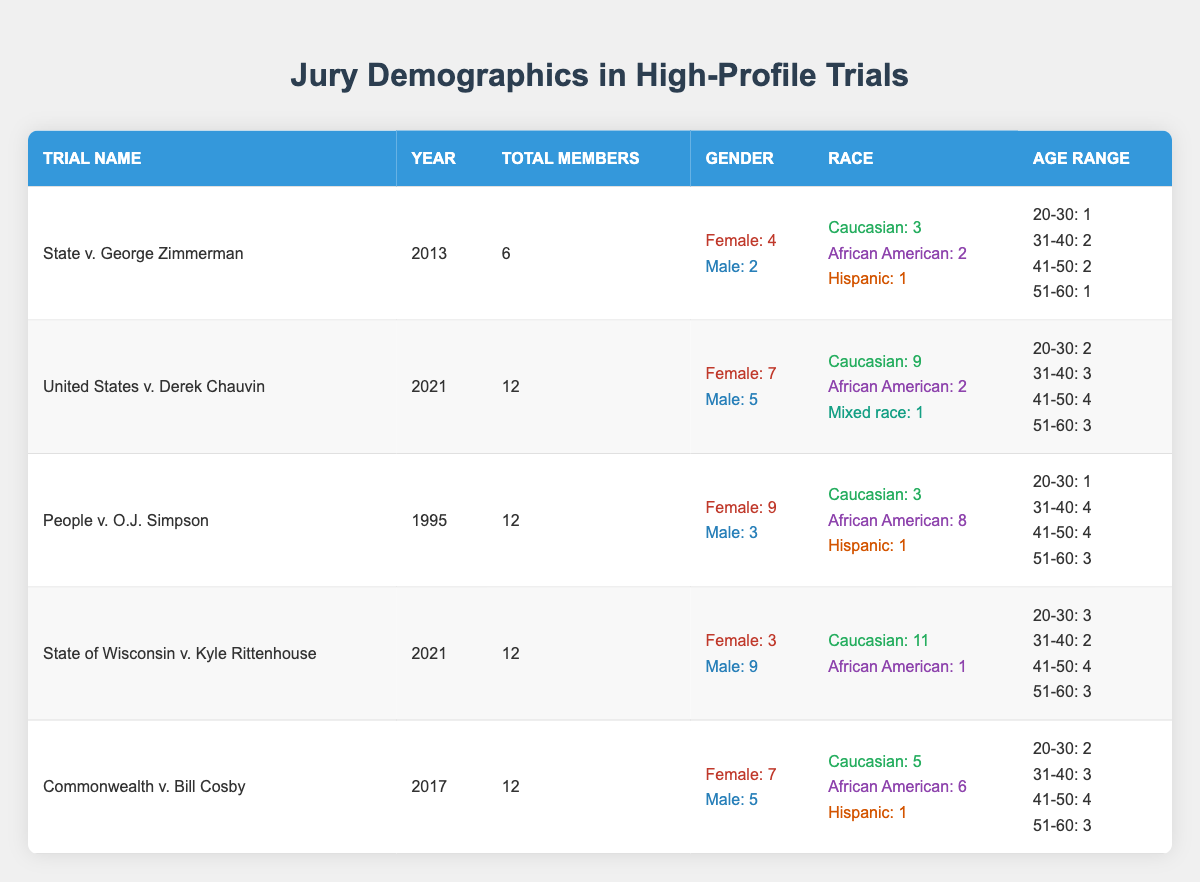What is the total number of jury members in the trial "State v. George Zimmerman"? The total number of jury members for this trial is directly stated in the table under the "Total Members" column. It shows that there are 6 jury members in that trial.
Answer: 6 What percentage of jury members were female in the "United States v. Derek Chauvin" trial? There are 12 total jury members, with 7 being female. To find the percentage, divide the number of females (7) by the total members (12) and multiply by 100: (7/12) * 100 = 58.33%.
Answer: 58.33% Was the jury in the "People v. O.J. Simpson" trial predominantly Caucasian? In the "People v. O.J. Simpson" trial, there are 12 jury members, of which 3 are Caucasian and 8 are African American; since the majority are African American, the jury was not predominantly Caucasian.
Answer: No How many jury members were aged 41-50 in the "Commonwealth v. Bill Cosby" trial? The table indicates that within the "Age Range" section for this trial, there are 4 jury members aged 41-50.
Answer: 4 What is the total number of male jury members across all trials listed? To find the total number of male jury members, sum the counts from each trial: 2 (Zimmerman) + 5 (Chauvin) + 3 (Simpson) + 9 (Rittenhouse) + 5 (Cosby) = 24 male jury members total across all trials.
Answer: 24 Which trial had the highest proportion of female jury members? To determine this, compare the proportions of female members: State v. George Zimmerman (4/6 = 66.67%), United States v. Derek Chauvin (7/12 = 58.33%), People v. O.J. Simpson (9/12 = 75%), State of Wisconsin v. Kyle Rittenhouse (3/12 = 25%), Commonwealth v. Bill Cosby (7/12 = 58.33%). The highest proportion is 75% for the O.J. Simpson trial.
Answer: People v. O.J. Simpson How many total jury members were aged 20-30 across all trials? Sum the numbers from the "Age Range" section for those aged 20-30: 1 (Zimmerman) + 2 (Chauvin) + 1 (Simpson) + 3 (Rittenhouse) + 2 (Cosby) = 9 total jury members aged 20-30 across all trials.
Answer: 9 Did any trial have a jury consisting entirely of Caucasian members? Looking through the jury demographic data, it's clear that the "State of Wisconsin v. Kyle Rittenhouse" trial had the highest number of Caucasian jury members (11 out of 12), but 1 member was African American. No trial had a jury consisting entirely of Caucasian members.
Answer: No What is the average age bracket representation for the "State of Wisconsin v. Kyle Rittenhouse" trial? For the age range breakdown, the representation is: 20-30: 3, 31-40: 2, 41-50: 4, 51-60: 3. To calculate the average, multiply each age bracket by its members, sum them, and divide by the total number of members: (3*25 + 2*35 + 4*45 + 3*55)/12 = (75 + 70 + 180 + 165)/12 = 490/12 = 40.83. The average age is approximately 40.83 years.
Answer: 40.83 